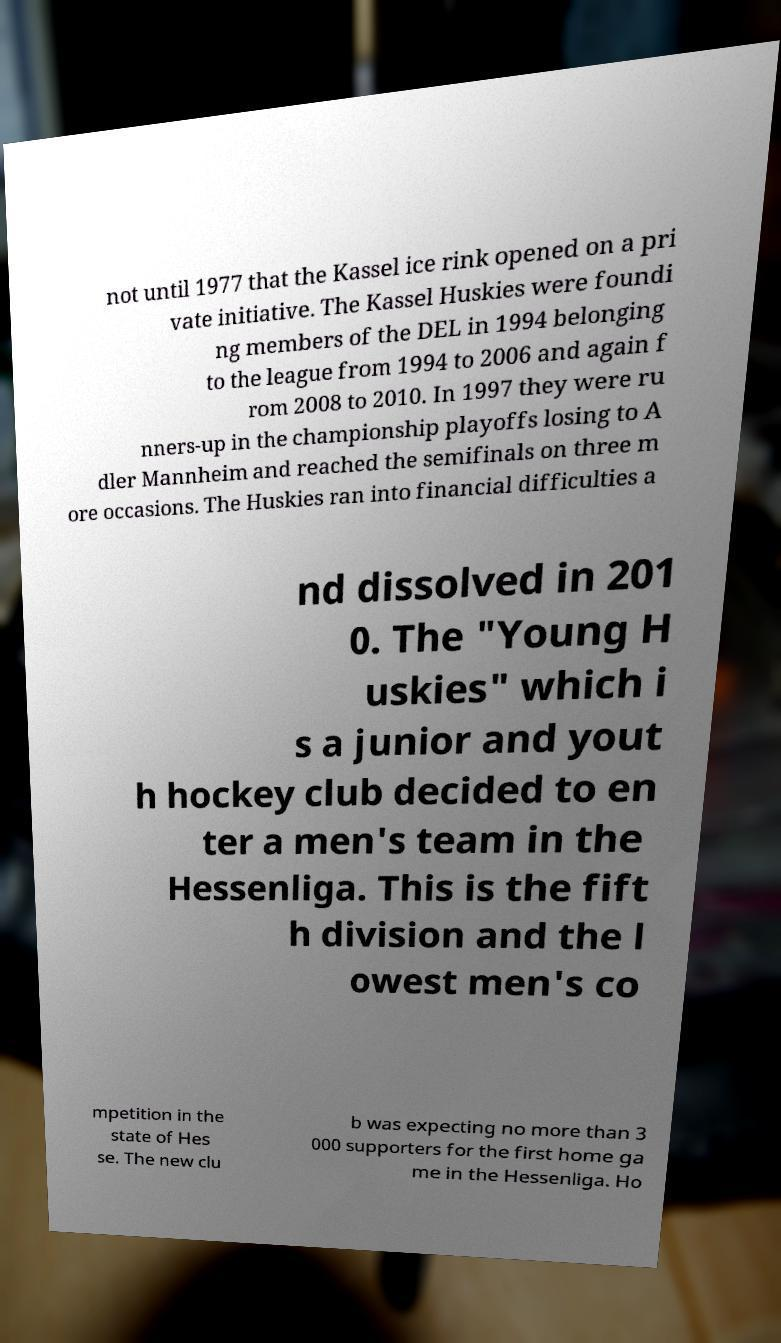Please read and relay the text visible in this image. What does it say? not until 1977 that the Kassel ice rink opened on a pri vate initiative. The Kassel Huskies were foundi ng members of the DEL in 1994 belonging to the league from 1994 to 2006 and again f rom 2008 to 2010. In 1997 they were ru nners-up in the championship playoffs losing to A dler Mannheim and reached the semifinals on three m ore occasions. The Huskies ran into financial difficulties a nd dissolved in 201 0. The "Young H uskies" which i s a junior and yout h hockey club decided to en ter a men's team in the Hessenliga. This is the fift h division and the l owest men's co mpetition in the state of Hes se. The new clu b was expecting no more than 3 000 supporters for the first home ga me in the Hessenliga. Ho 